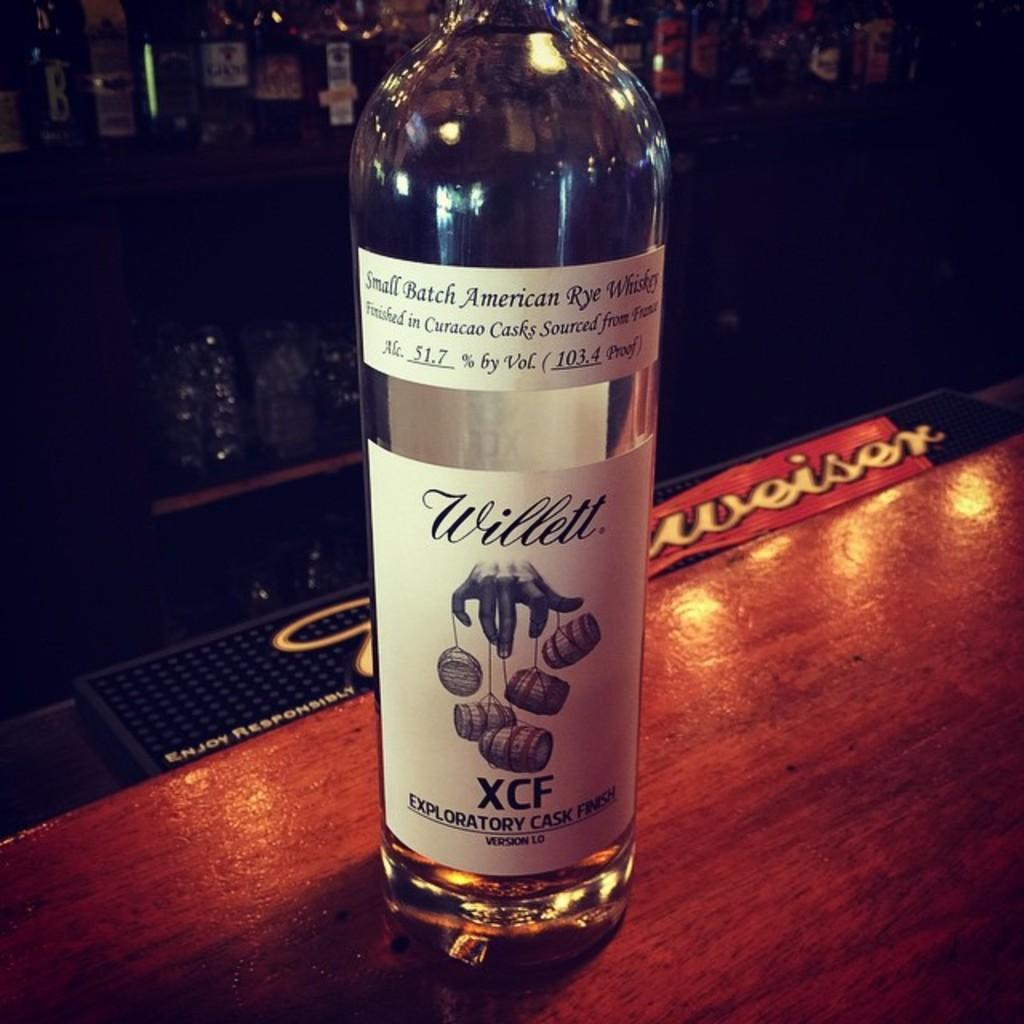<image>
Offer a succinct explanation of the picture presented. A bottle of Willet small batch American rye whiskey sits on a wooden bartop. 